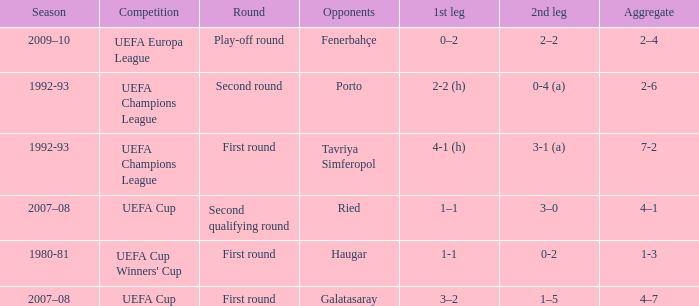What is the total number of round where opponents is haugar 1.0. 